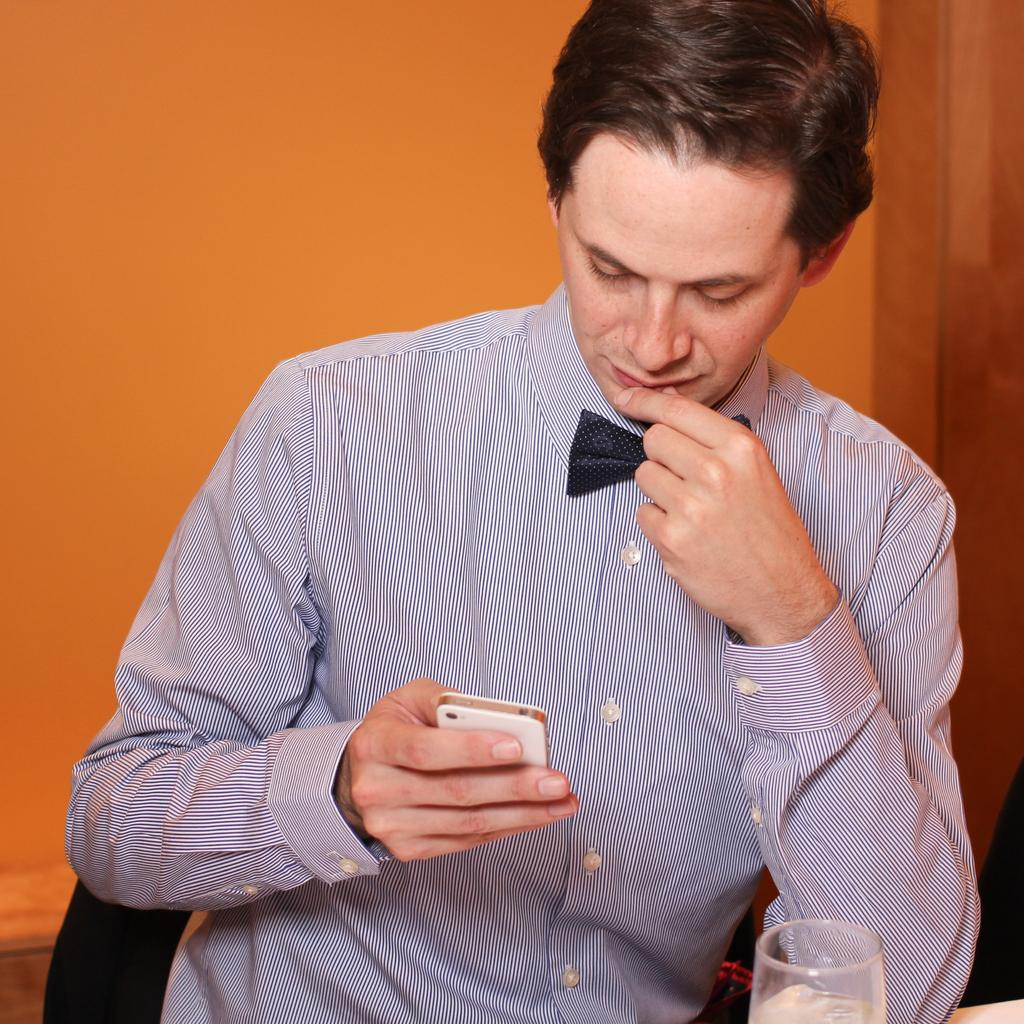What is the person in the image doing? There is a person sitting on a chair in the image. What object is the person holding? The person is holding a phone. What can be seen in front of the person? There is a glass in front of the person. What type of song is the person singing in the image? There is no indication in the image that the person is singing a song. 